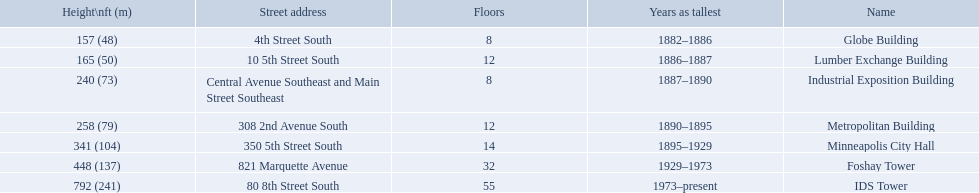Which buildings have the same number of floors as another building? Globe Building, Lumber Exchange Building, Industrial Exposition Building, Metropolitan Building. Of those, which has the same as the lumber exchange building? Metropolitan Building. 